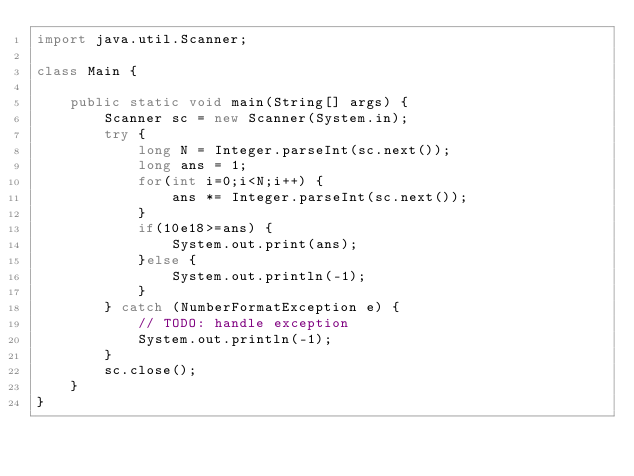<code> <loc_0><loc_0><loc_500><loc_500><_Java_>import java.util.Scanner;

class Main {

	public static void main(String[] args) {
		Scanner sc = new Scanner(System.in);
		try {
			long N = Integer.parseInt(sc.next());
			long ans = 1;
			for(int i=0;i<N;i++) {
				ans *= Integer.parseInt(sc.next());
			}
			if(10e18>=ans) {
				System.out.print(ans);
			}else {
				System.out.println(-1);
			}
		} catch (NumberFormatException e) {
			// TODO: handle exception
			System.out.println(-1);
		}
		sc.close();
	}
}</code> 